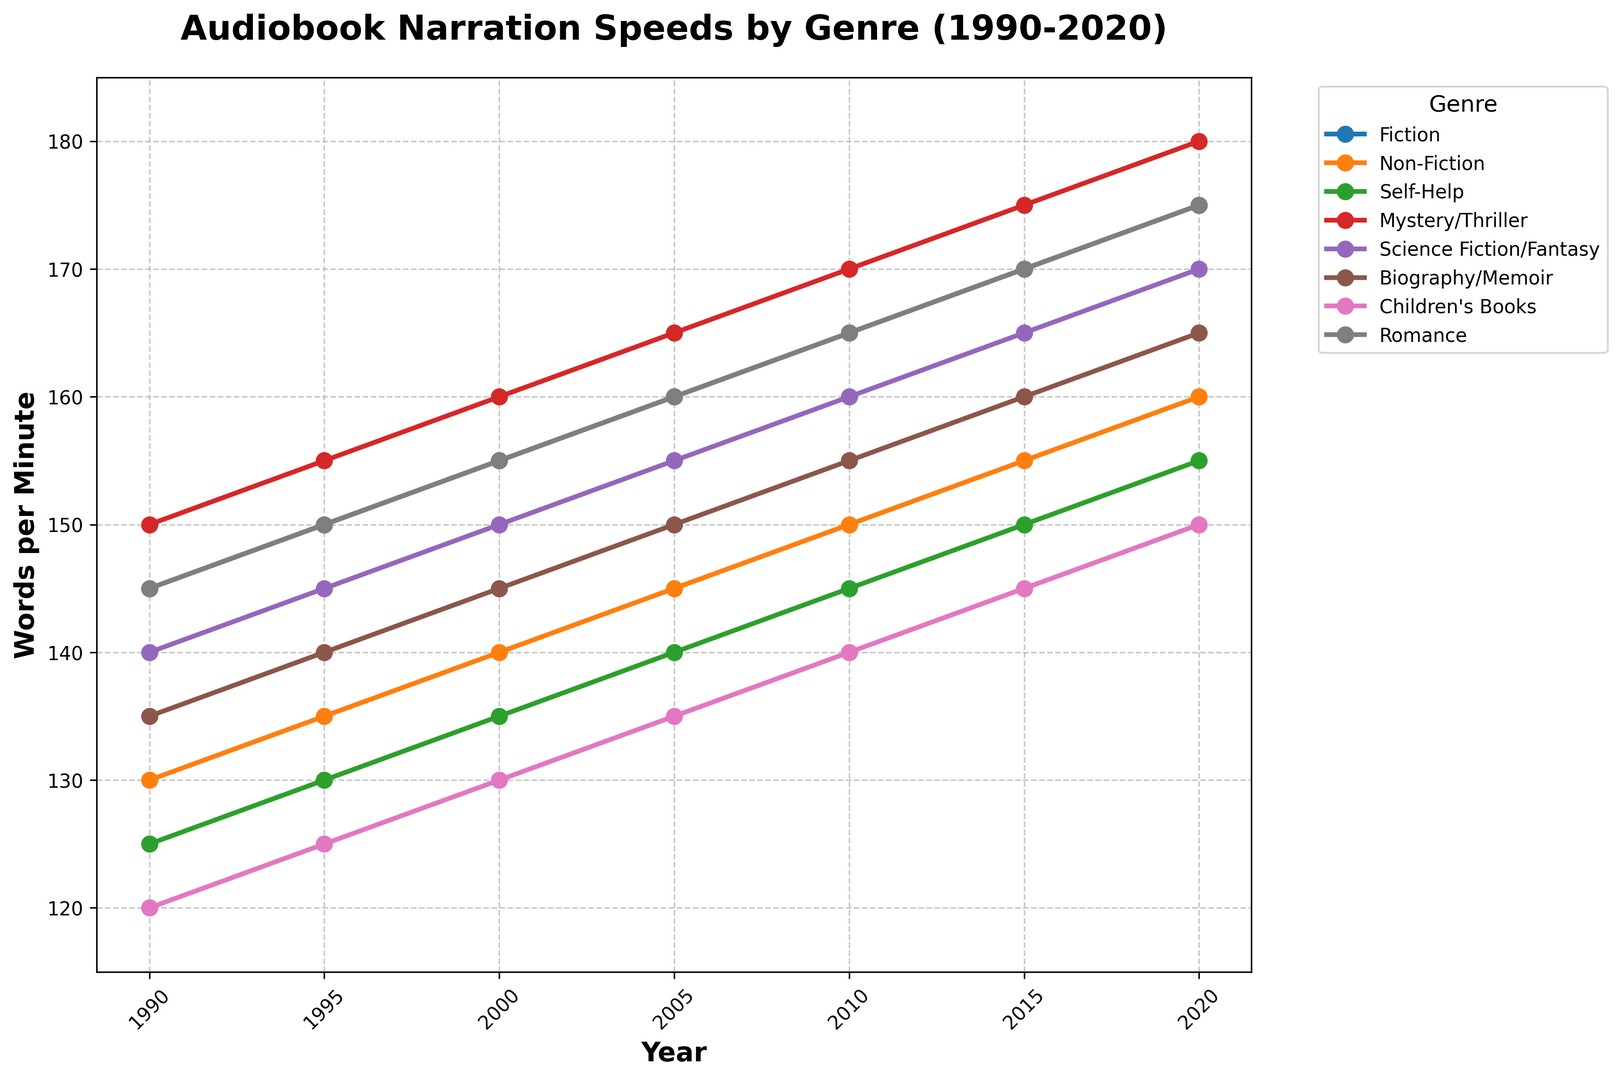What is the trend in narration speed for Fiction from 1990 to 2020? Start by looking at the line representing Fiction which shows data points from 1990 to 2020. Notice the slope and overall trend. From 1990 to 2020, the narration speed increased steadily from 145 words per minute to 175 words per minute.
Answer: Steady increase Which genre had the slowest narration speed in 1990? Refer to the graph and check the narration speeds for all genres in 1990. The Children's Books genre had the slowest narration speed at 120 words per minute.
Answer: Children's Books How does the average narration speed of Mystery/Thriller compare to Science Fiction/Fantasy in 2020? Calculate the average for each genre over the years and compare their values in 2020. The average narration speed for Mystery/Thriller in 2020 is 180 words per minute and for Science Fiction/Fantasy, it is 170 words per minute.
Answer: Mystery/Thriller is higher By how much did the narration speed for Non-Fiction increase from 1990 to 2020? Find the narration speeds for Non-Fiction in 1990 and 2020, then subtract the former from the latter. The narration speed increased from 130 words per minute in 1990 to 160 words per minute in 2020, making the increase 30 words per minute.
Answer: 30 words per minute Which genre had the most significant increase in narration speed from 1990 to 2020, and by how much? Check the difference between 1990 and 2020 for all genres and find the maximum. The Mystery/Thriller genre had the largest increase in narration speed, from 150 words per minute in 1990 to 180 words per minute in 2020, which is an increase of 30 words per minute.
Answer: Mystery/Thriller, 30 words per minute What is the difference in narration speed between Fiction and Romance in 2010? Look at the narration speeds for Fiction and Romance in 2010 and subtract one from the other. Both genres had the same narration speed of 165 words per minute, so the difference is 0.
Answer: 0 Which genre had the fastest narration speed in 2020? Check the narration speeds for all genres in 2020 and identify the maximum. The Mystery/Thriller genre had the fastest narration speed at 180 words per minute.
Answer: Mystery/Thriller What visual attributes help identify the genres in the plot? The plot uses different colored lines and markers to distinguish between genres. The legend on the right side of the plot indicates which color and marker represent each genre.
Answer: Different colored lines and markers 